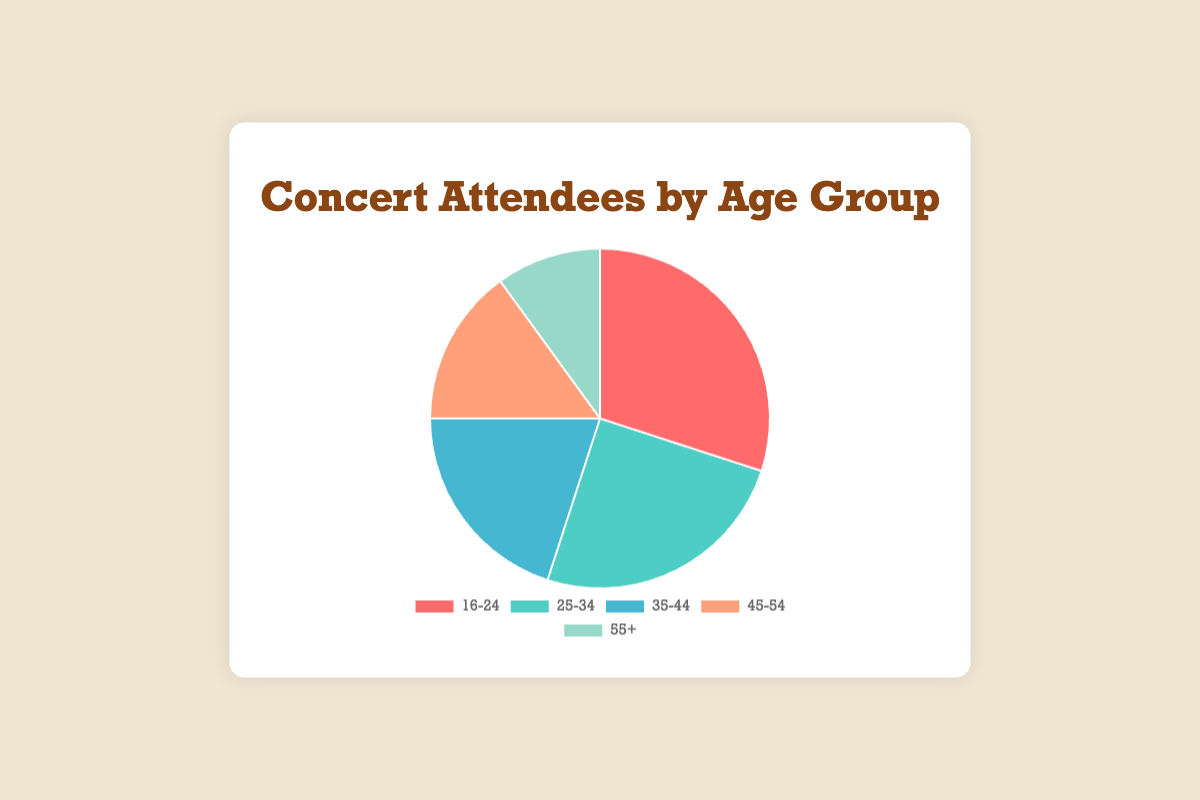What age group has the highest proportion of concert attendees? The chart shows that the largest section of the pie represents the age group 16-24. With 30% of the attendees, this age group has the highest proportion.
Answer: 16-24 Which two age groups together make up more than half of the attendees? The age groups 16-24 and 25-34 have 30% and 25% respectively. Adding them together gives 30% + 25% = 55%, which is more than half of the total attendees.
Answer: 16-24 and 25-34 What is the difference in percentage points between the 16-24 and 55+ age groups? The 16-24 age group has 30% while the 55+ age group has 10%. The difference is calculated by 30% - 10% = 20 percentage points.
Answer: 20 percentage points Which age group is represented by the blue section of the pie chart? According to the color scheme provided in the description, the blue section represents the 35-44 age group.
Answer: 35-44 Is the proportion of attendees aged 35-54 greater than or less than one-third of the total attendees? The age groups 35-44 and 45-54 have 20% and 15% respectively. Adding them gives 20% + 15% = 35%, which is greater than one-third (33.33%) of the total attendees.
Answer: Greater than What is the total percentage of attendees aged 25 and above? Summing up the percentages of the 25-34, 35-44, 45-54, and 55+ age groups gives 25% + 20% + 15% + 10% = 70%.
Answer: 70% How many percentage points do the 45-54 and 55+ age groups differ by? The 45-54 age group has 15% while the 55+ age group has 10%. The difference is 15% - 10% = 5 percentage points.
Answer: 5 percentage points 